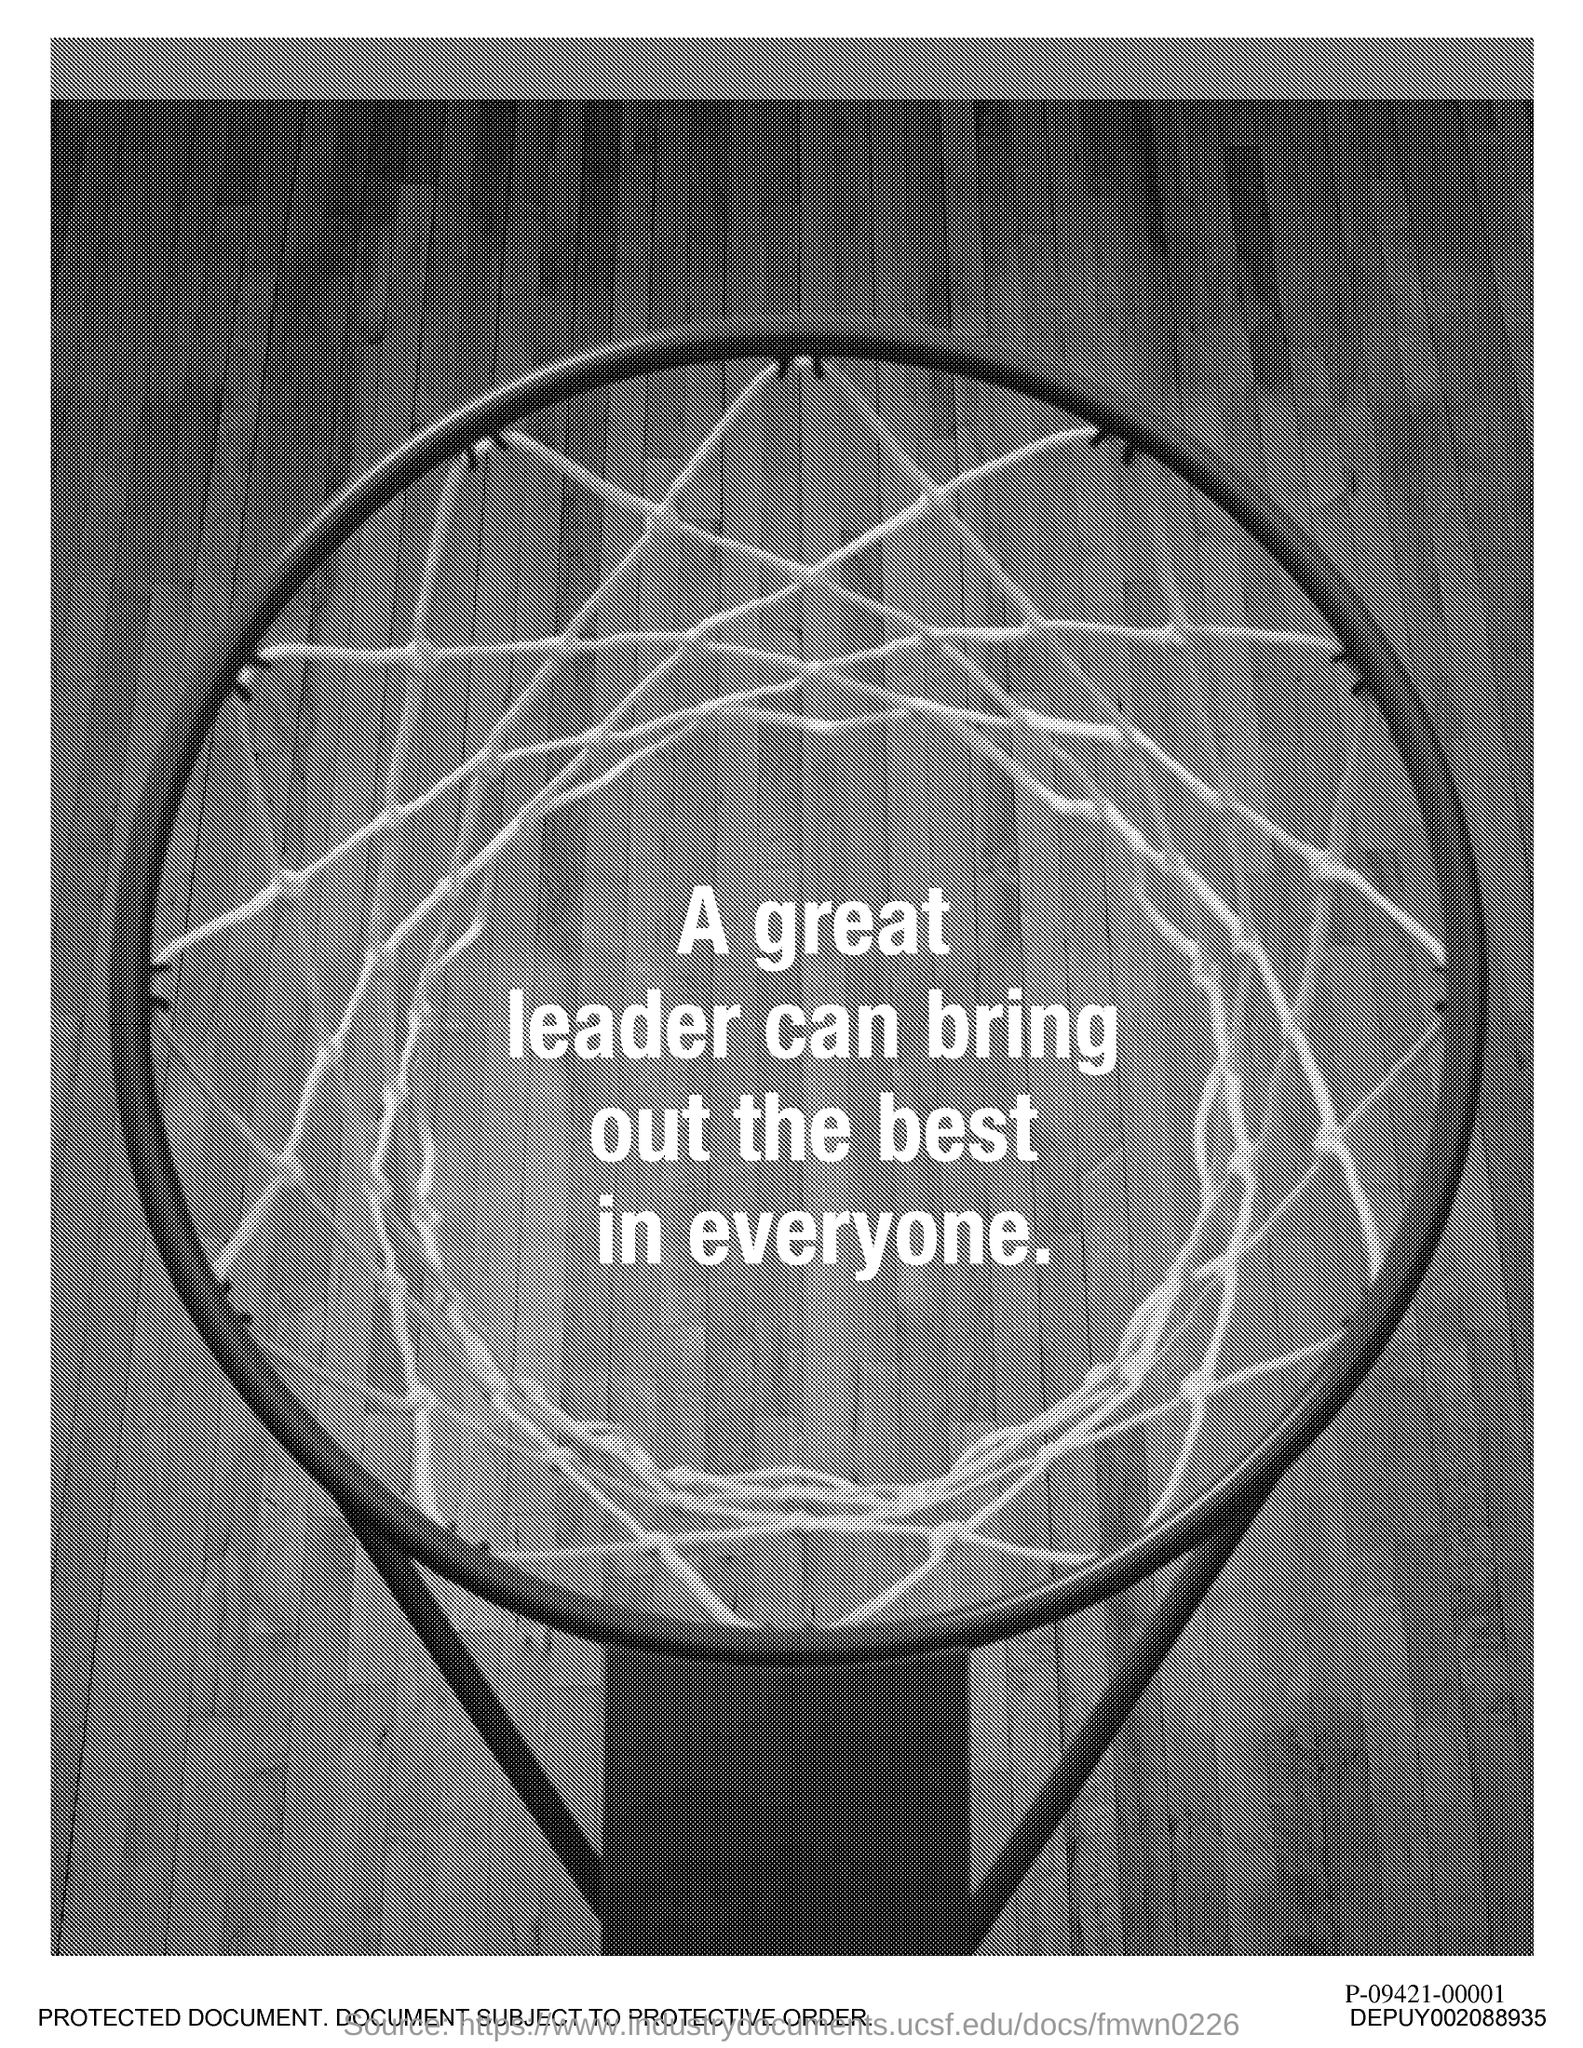Draw attention to some important aspects in this diagram. A great leader has the ability to bring out the best in everyone. A great leader brings out the best in everyone by inspiring, motivating, and empowering them to reach their full potential. 